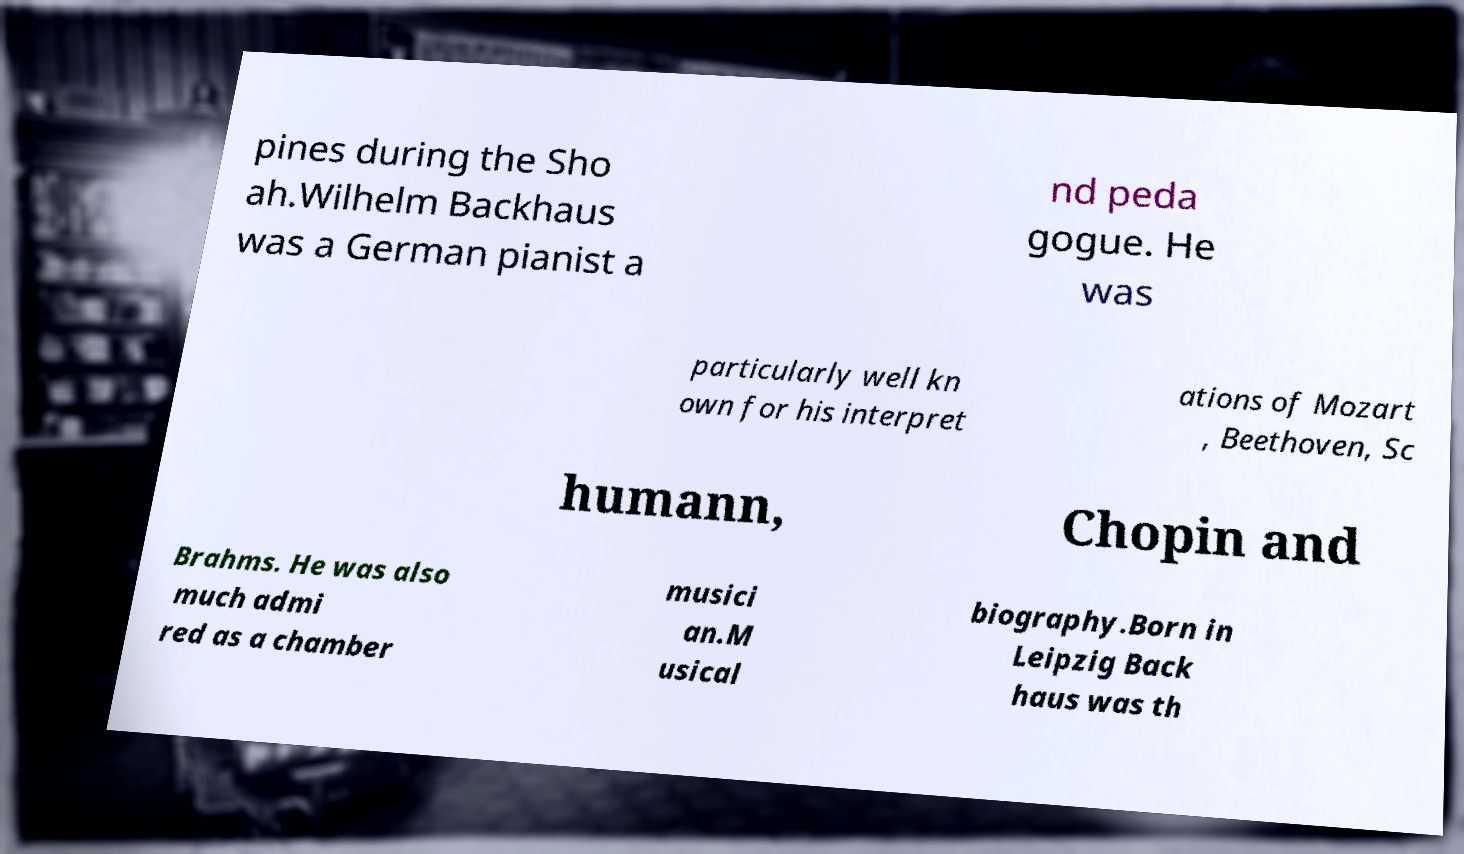Can you read and provide the text displayed in the image?This photo seems to have some interesting text. Can you extract and type it out for me? pines during the Sho ah.Wilhelm Backhaus was a German pianist a nd peda gogue. He was particularly well kn own for his interpret ations of Mozart , Beethoven, Sc humann, Chopin and Brahms. He was also much admi red as a chamber musici an.M usical biography.Born in Leipzig Back haus was th 